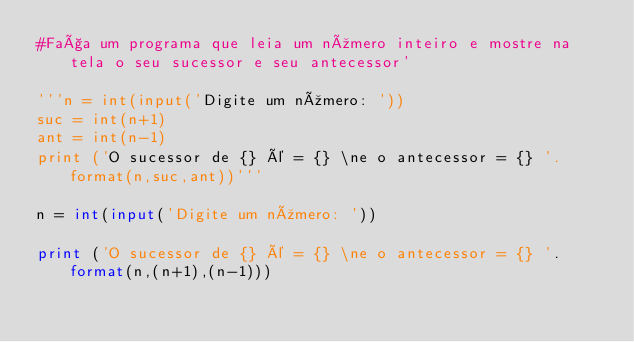Convert code to text. <code><loc_0><loc_0><loc_500><loc_500><_Python_>#Faça um programa que leia um número inteiro e mostre na tela o seu sucessor e seu antecessor'

'''n = int(input('Digite um número: '))
suc = int(n+1)
ant = int(n-1)
print ('O sucessor de {} é = {} \ne o antecessor = {} '.format(n,suc,ant))'''

n = int(input('Digite um número: '))

print ('O sucessor de {} é = {} \ne o antecessor = {} '.format(n,(n+1),(n-1)))</code> 